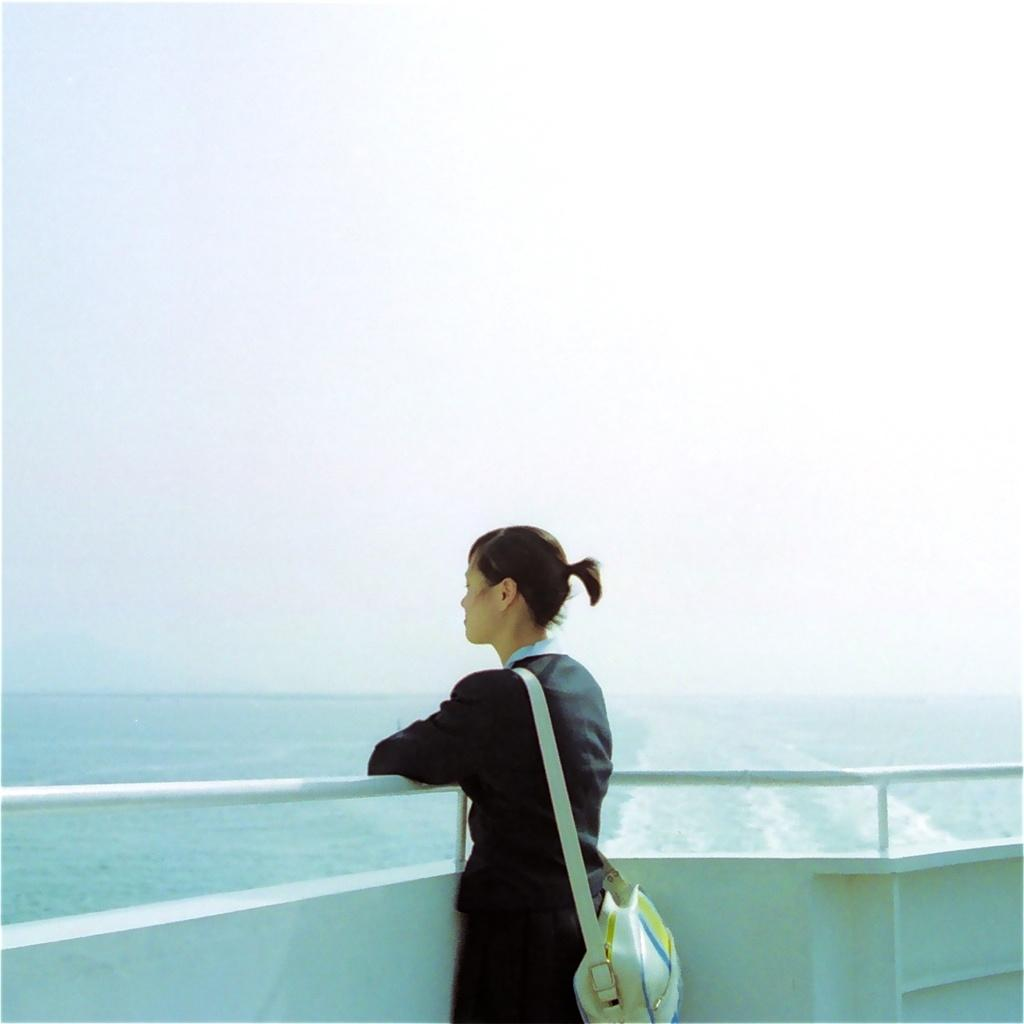What is the main setting of the image? There is a sea in the image. What is located on the sea? There is a boat on the sea. What is visible at the top of the image? The sky is visible at the top of the image. Who is present in the image? There is a woman in the image. What is the woman wearing? The woman is wearing a bag. Where is the woman standing in the image? The woman is standing on the boat. What type of paste is the crow eating in the image? There is no crow or paste present in the image. How many bags is the woman carrying in the image? The woman is wearing a bag, but there is no mention of her carrying multiple bags. 